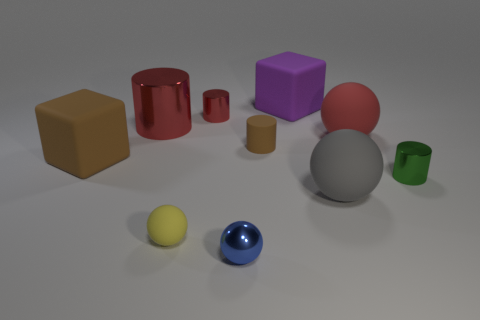If you had to guess, what purpose do these objects serve? These objects may be part of a visual study or a demonstration of geometrical shapes and materials in a 3D modeling software. Their purpose could be educational, to illustrate lighting effects, texturing, or color theory in a controlled setting. 